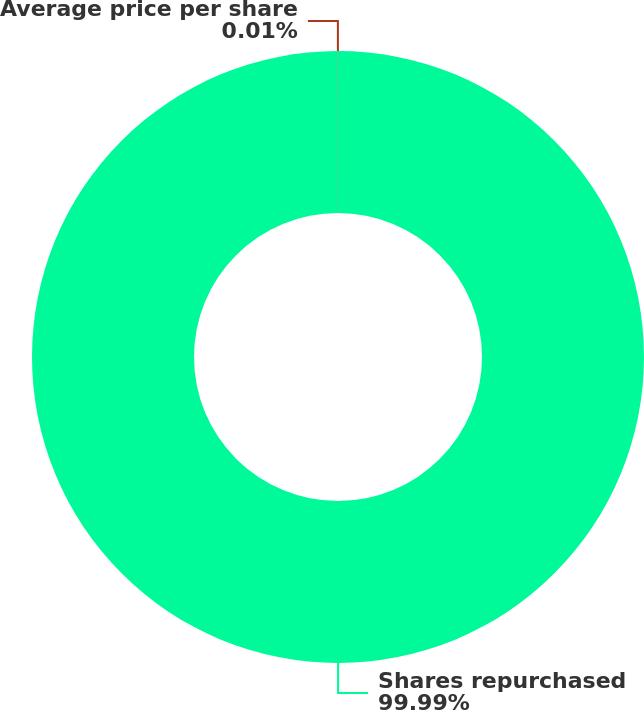<chart> <loc_0><loc_0><loc_500><loc_500><pie_chart><fcel>Shares repurchased<fcel>Average price per share<nl><fcel>99.99%<fcel>0.01%<nl></chart> 